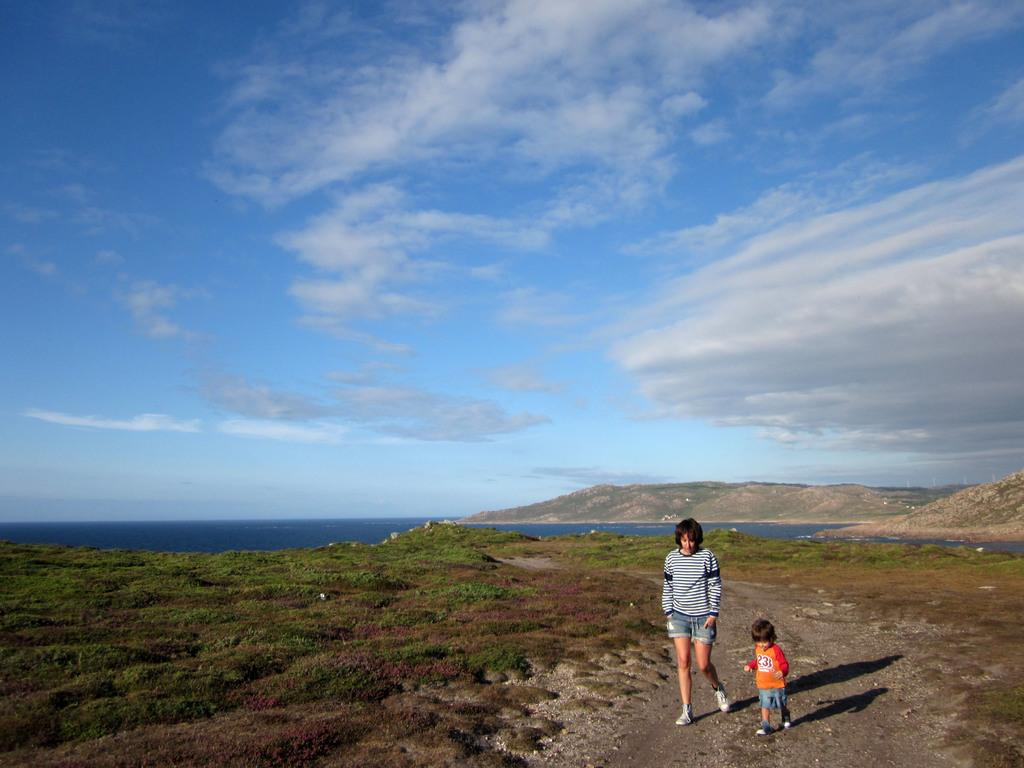Who is present in the image? There is a person and a child in the image. What is the ground made of in the image? There is grass on the ground in the image. What can be seen in the background of the image? There is water and a hill visible in the background of the image. What is visible in the sky in the image? The sky is visible in the image, and there are clouds in the sky. What type of debt is the person in the image dealing with? There is no indication of debt in the image; it only shows a person, a child, grass, water, a hill, and the sky with clouds. 